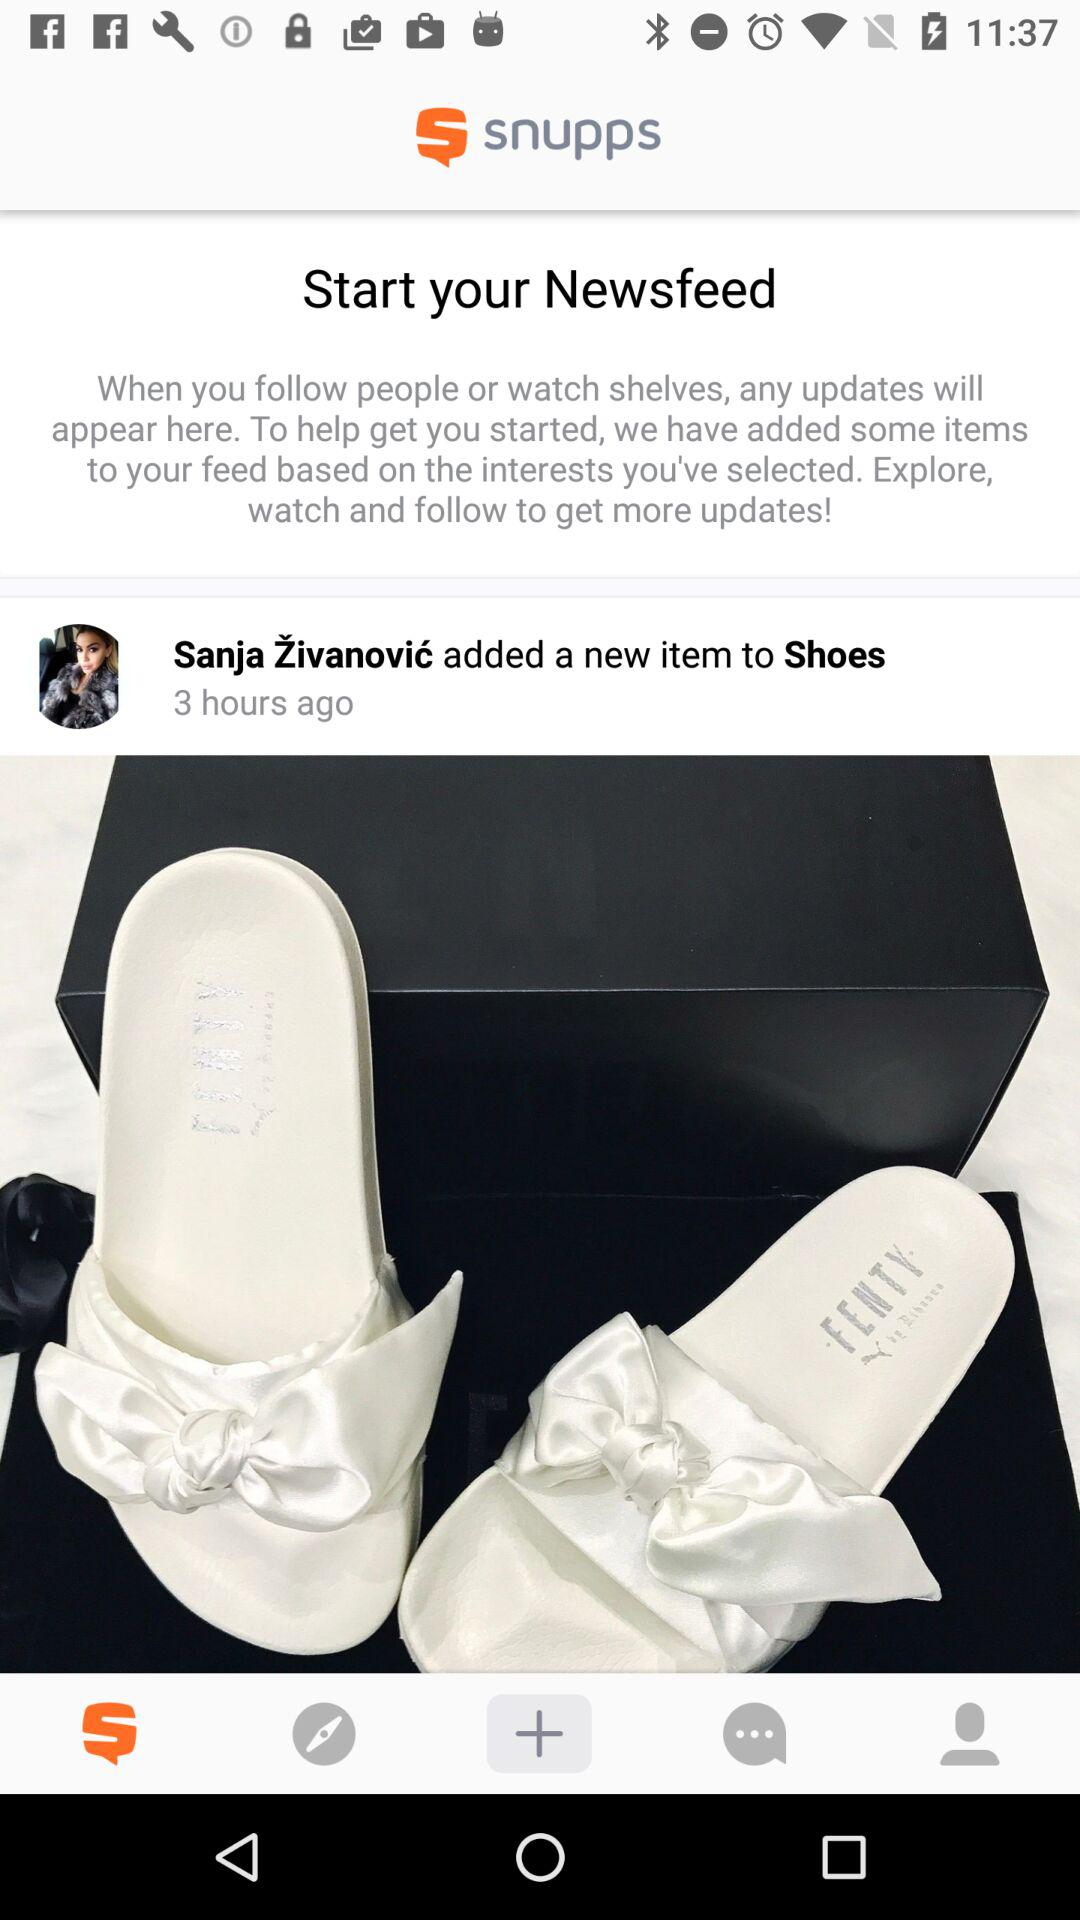Who added a new item to "Shoes"? A new item to "Shoes" is added by Sanja Živanović. 